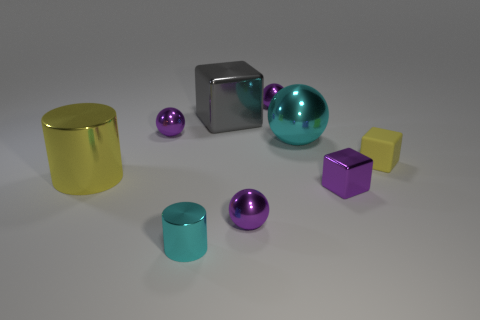Subtract all purple spheres. How many were subtracted if there are1purple spheres left? 2 Subtract all big metallic balls. How many balls are left? 3 Subtract all cylinders. How many objects are left? 7 Subtract 1 cylinders. How many cylinders are left? 1 Add 6 tiny purple metal spheres. How many tiny purple metal spheres exist? 9 Add 1 spheres. How many objects exist? 10 Subtract all yellow cubes. How many cubes are left? 2 Subtract 0 gray cylinders. How many objects are left? 9 Subtract all yellow cylinders. Subtract all blue balls. How many cylinders are left? 1 Subtract all gray cylinders. How many blue spheres are left? 0 